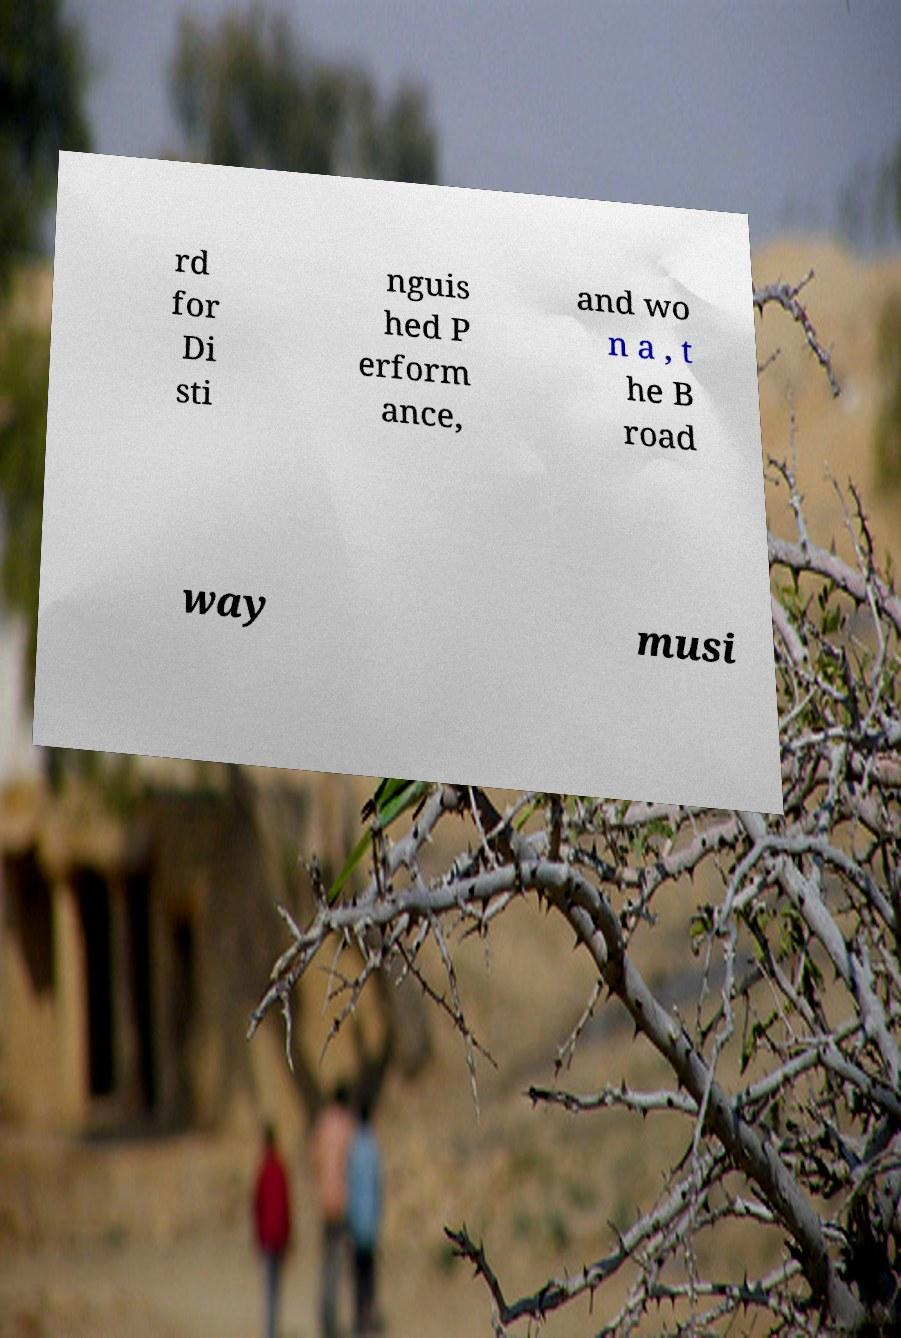Please identify and transcribe the text found in this image. rd for Di sti nguis hed P erform ance, and wo n a , t he B road way musi 